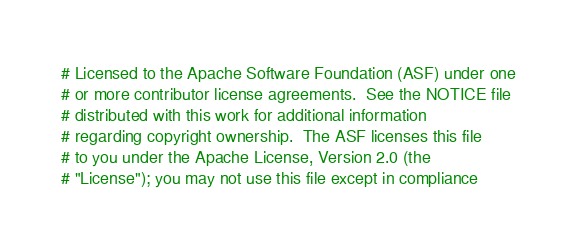Convert code to text. <code><loc_0><loc_0><loc_500><loc_500><_Python_># Licensed to the Apache Software Foundation (ASF) under one
# or more contributor license agreements.  See the NOTICE file
# distributed with this work for additional information
# regarding copyright ownership.  The ASF licenses this file
# to you under the Apache License, Version 2.0 (the
# "License"); you may not use this file except in compliance</code> 